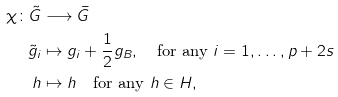Convert formula to latex. <formula><loc_0><loc_0><loc_500><loc_500>\chi \colon \tilde { G } & \longrightarrow \bar { G } \\ \tilde { g } _ { i } & \mapsto g _ { i } + \frac { 1 } { 2 } g _ { B } , \quad \text {for any $i=1,\dots,p+2s$} \\ h & \mapsto h \quad \text {for any $h\in H$} ,</formula> 